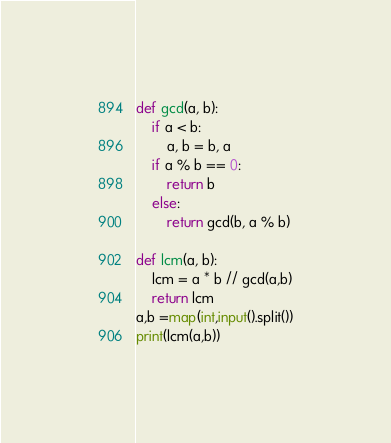<code> <loc_0><loc_0><loc_500><loc_500><_Python_>def gcd(a, b):
    if a < b:
        a, b = b, a
    if a % b == 0:
        return b
    else:
        return gcd(b, a % b)

def lcm(a, b):
    lcm = a * b // gcd(a,b)
    return lcm
a,b =map(int,input().split())
print(lcm(a,b))</code> 